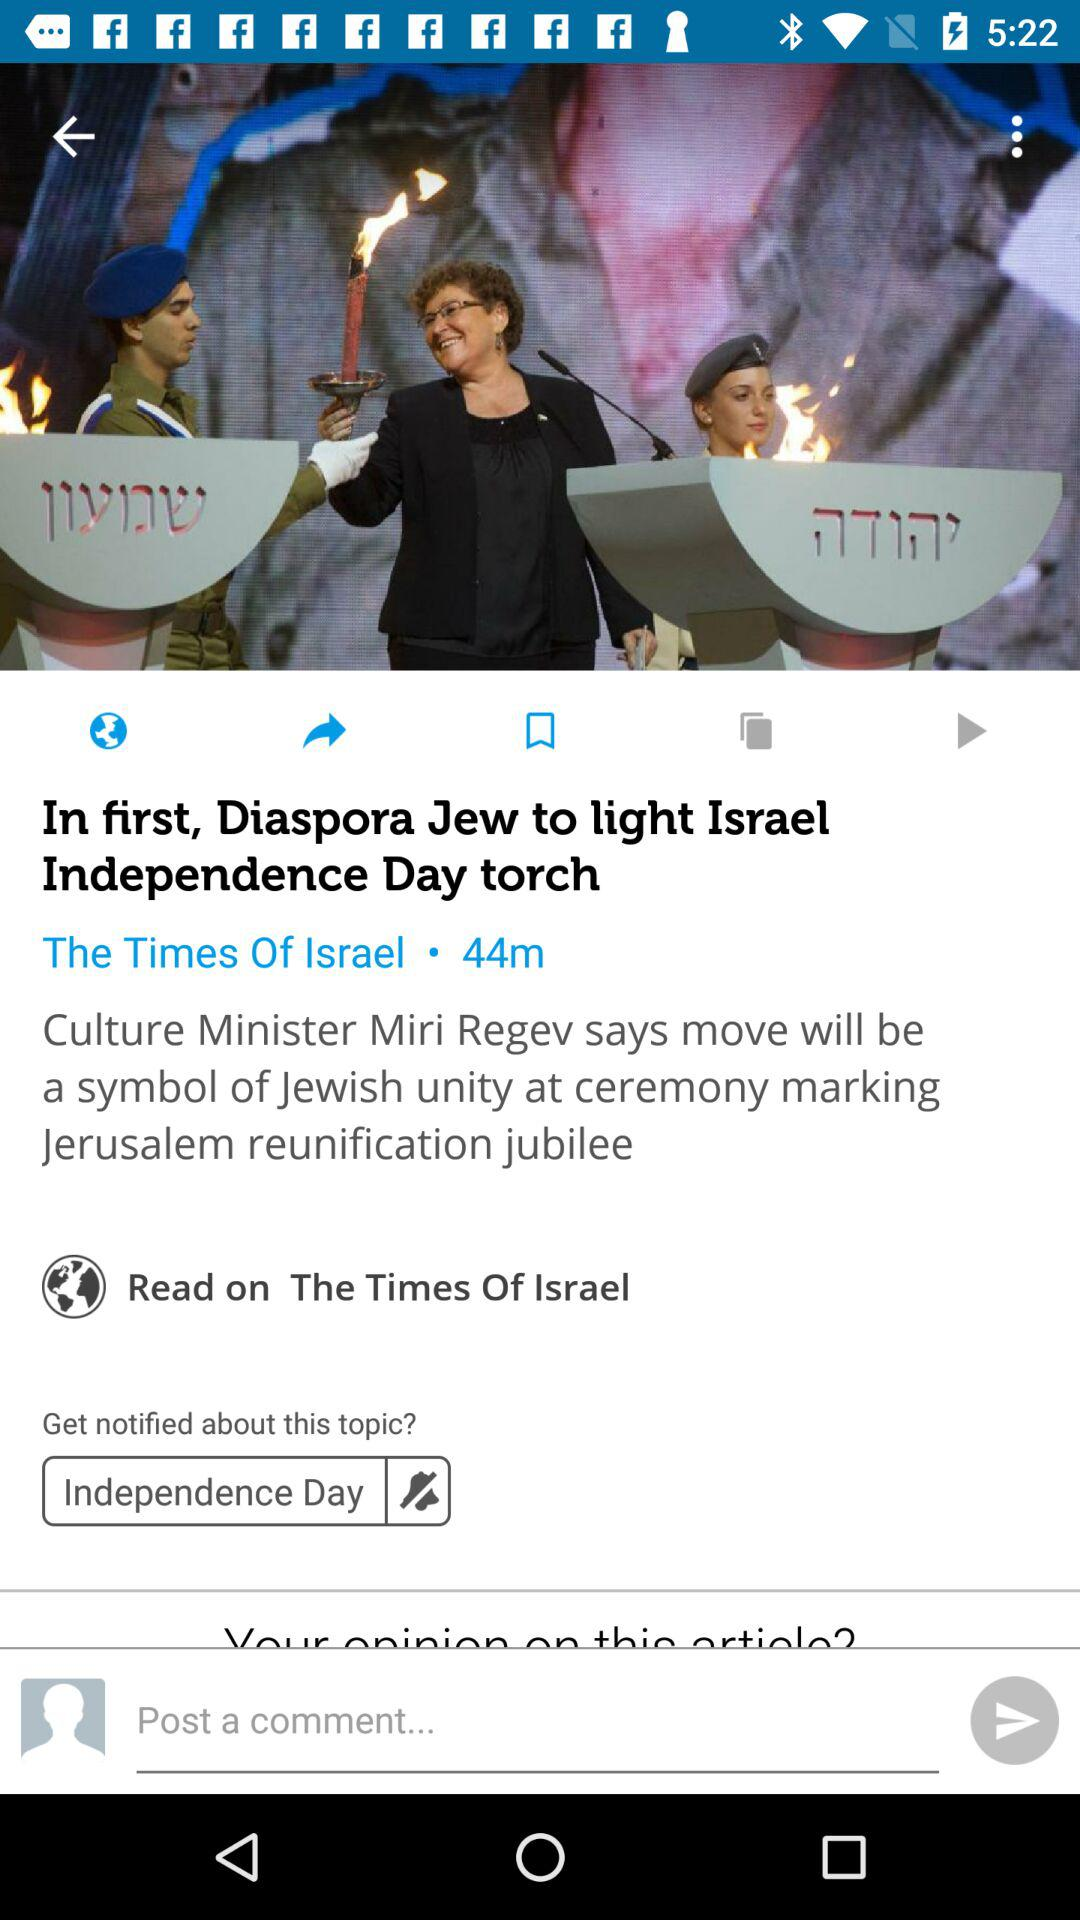For what day is the notification setting disabled? The notification setting is disabled for Independence Day. 